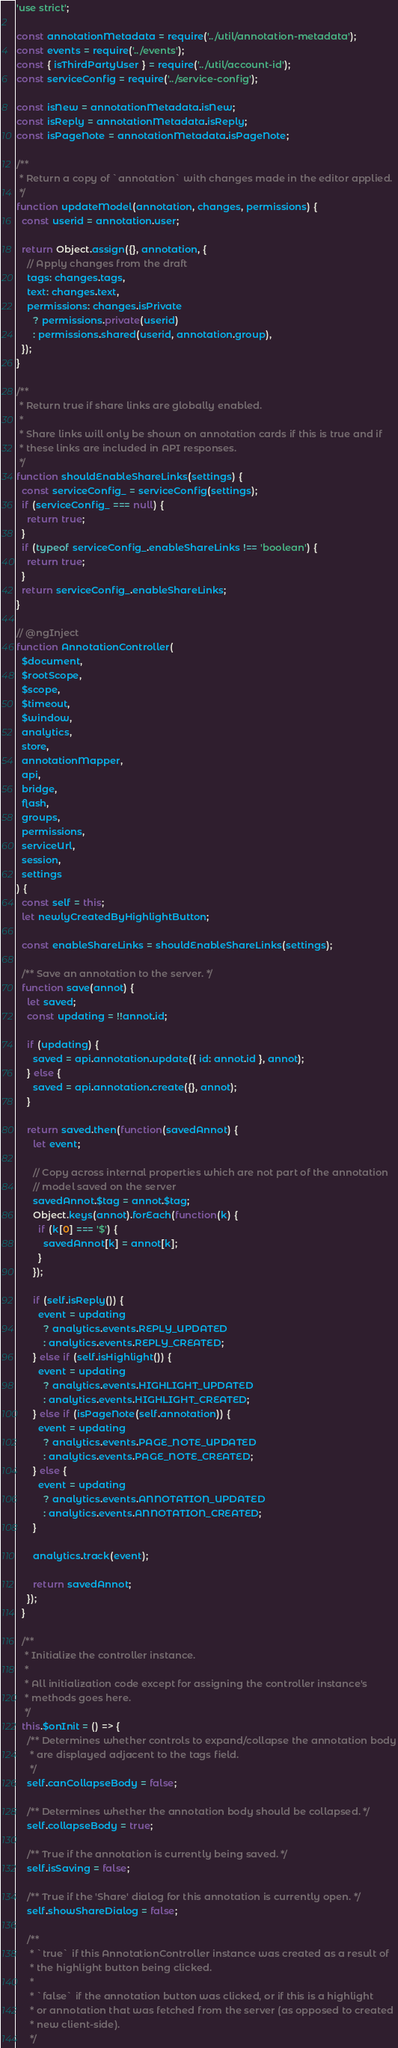<code> <loc_0><loc_0><loc_500><loc_500><_JavaScript_>'use strict';

const annotationMetadata = require('../util/annotation-metadata');
const events = require('../events');
const { isThirdPartyUser } = require('../util/account-id');
const serviceConfig = require('../service-config');

const isNew = annotationMetadata.isNew;
const isReply = annotationMetadata.isReply;
const isPageNote = annotationMetadata.isPageNote;

/**
 * Return a copy of `annotation` with changes made in the editor applied.
 */
function updateModel(annotation, changes, permissions) {
  const userid = annotation.user;

  return Object.assign({}, annotation, {
    // Apply changes from the draft
    tags: changes.tags,
    text: changes.text,
    permissions: changes.isPrivate
      ? permissions.private(userid)
      : permissions.shared(userid, annotation.group),
  });
}

/**
 * Return true if share links are globally enabled.
 *
 * Share links will only be shown on annotation cards if this is true and if
 * these links are included in API responses.
 */
function shouldEnableShareLinks(settings) {
  const serviceConfig_ = serviceConfig(settings);
  if (serviceConfig_ === null) {
    return true;
  }
  if (typeof serviceConfig_.enableShareLinks !== 'boolean') {
    return true;
  }
  return serviceConfig_.enableShareLinks;
}

// @ngInject
function AnnotationController(
  $document,
  $rootScope,
  $scope,
  $timeout,
  $window,
  analytics,
  store,
  annotationMapper,
  api,
  bridge,
  flash,
  groups,
  permissions,
  serviceUrl,
  session,
  settings
) {
  const self = this;
  let newlyCreatedByHighlightButton;

  const enableShareLinks = shouldEnableShareLinks(settings);

  /** Save an annotation to the server. */
  function save(annot) {
    let saved;
    const updating = !!annot.id;

    if (updating) {
      saved = api.annotation.update({ id: annot.id }, annot);
    } else {
      saved = api.annotation.create({}, annot);
    }

    return saved.then(function(savedAnnot) {
      let event;

      // Copy across internal properties which are not part of the annotation
      // model saved on the server
      savedAnnot.$tag = annot.$tag;
      Object.keys(annot).forEach(function(k) {
        if (k[0] === '$') {
          savedAnnot[k] = annot[k];
        }
      });

      if (self.isReply()) {
        event = updating
          ? analytics.events.REPLY_UPDATED
          : analytics.events.REPLY_CREATED;
      } else if (self.isHighlight()) {
        event = updating
          ? analytics.events.HIGHLIGHT_UPDATED
          : analytics.events.HIGHLIGHT_CREATED;
      } else if (isPageNote(self.annotation)) {
        event = updating
          ? analytics.events.PAGE_NOTE_UPDATED
          : analytics.events.PAGE_NOTE_CREATED;
      } else {
        event = updating
          ? analytics.events.ANNOTATION_UPDATED
          : analytics.events.ANNOTATION_CREATED;
      }

      analytics.track(event);

      return savedAnnot;
    });
  }

  /**
   * Initialize the controller instance.
   *
   * All initialization code except for assigning the controller instance's
   * methods goes here.
   */
  this.$onInit = () => {
    /** Determines whether controls to expand/collapse the annotation body
     * are displayed adjacent to the tags field.
     */
    self.canCollapseBody = false;

    /** Determines whether the annotation body should be collapsed. */
    self.collapseBody = true;

    /** True if the annotation is currently being saved. */
    self.isSaving = false;

    /** True if the 'Share' dialog for this annotation is currently open. */
    self.showShareDialog = false;

    /**
     * `true` if this AnnotationController instance was created as a result of
     * the highlight button being clicked.
     *
     * `false` if the annotation button was clicked, or if this is a highlight
     * or annotation that was fetched from the server (as opposed to created
     * new client-side).
     */</code> 